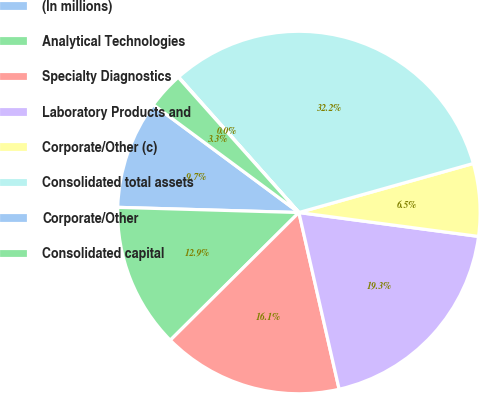<chart> <loc_0><loc_0><loc_500><loc_500><pie_chart><fcel>(In millions)<fcel>Analytical Technologies<fcel>Specialty Diagnostics<fcel>Laboratory Products and<fcel>Corporate/Other (c)<fcel>Consolidated total assets<fcel>Corporate/Other<fcel>Consolidated capital<nl><fcel>9.69%<fcel>12.9%<fcel>16.12%<fcel>19.33%<fcel>6.47%<fcel>32.19%<fcel>0.04%<fcel>3.26%<nl></chart> 